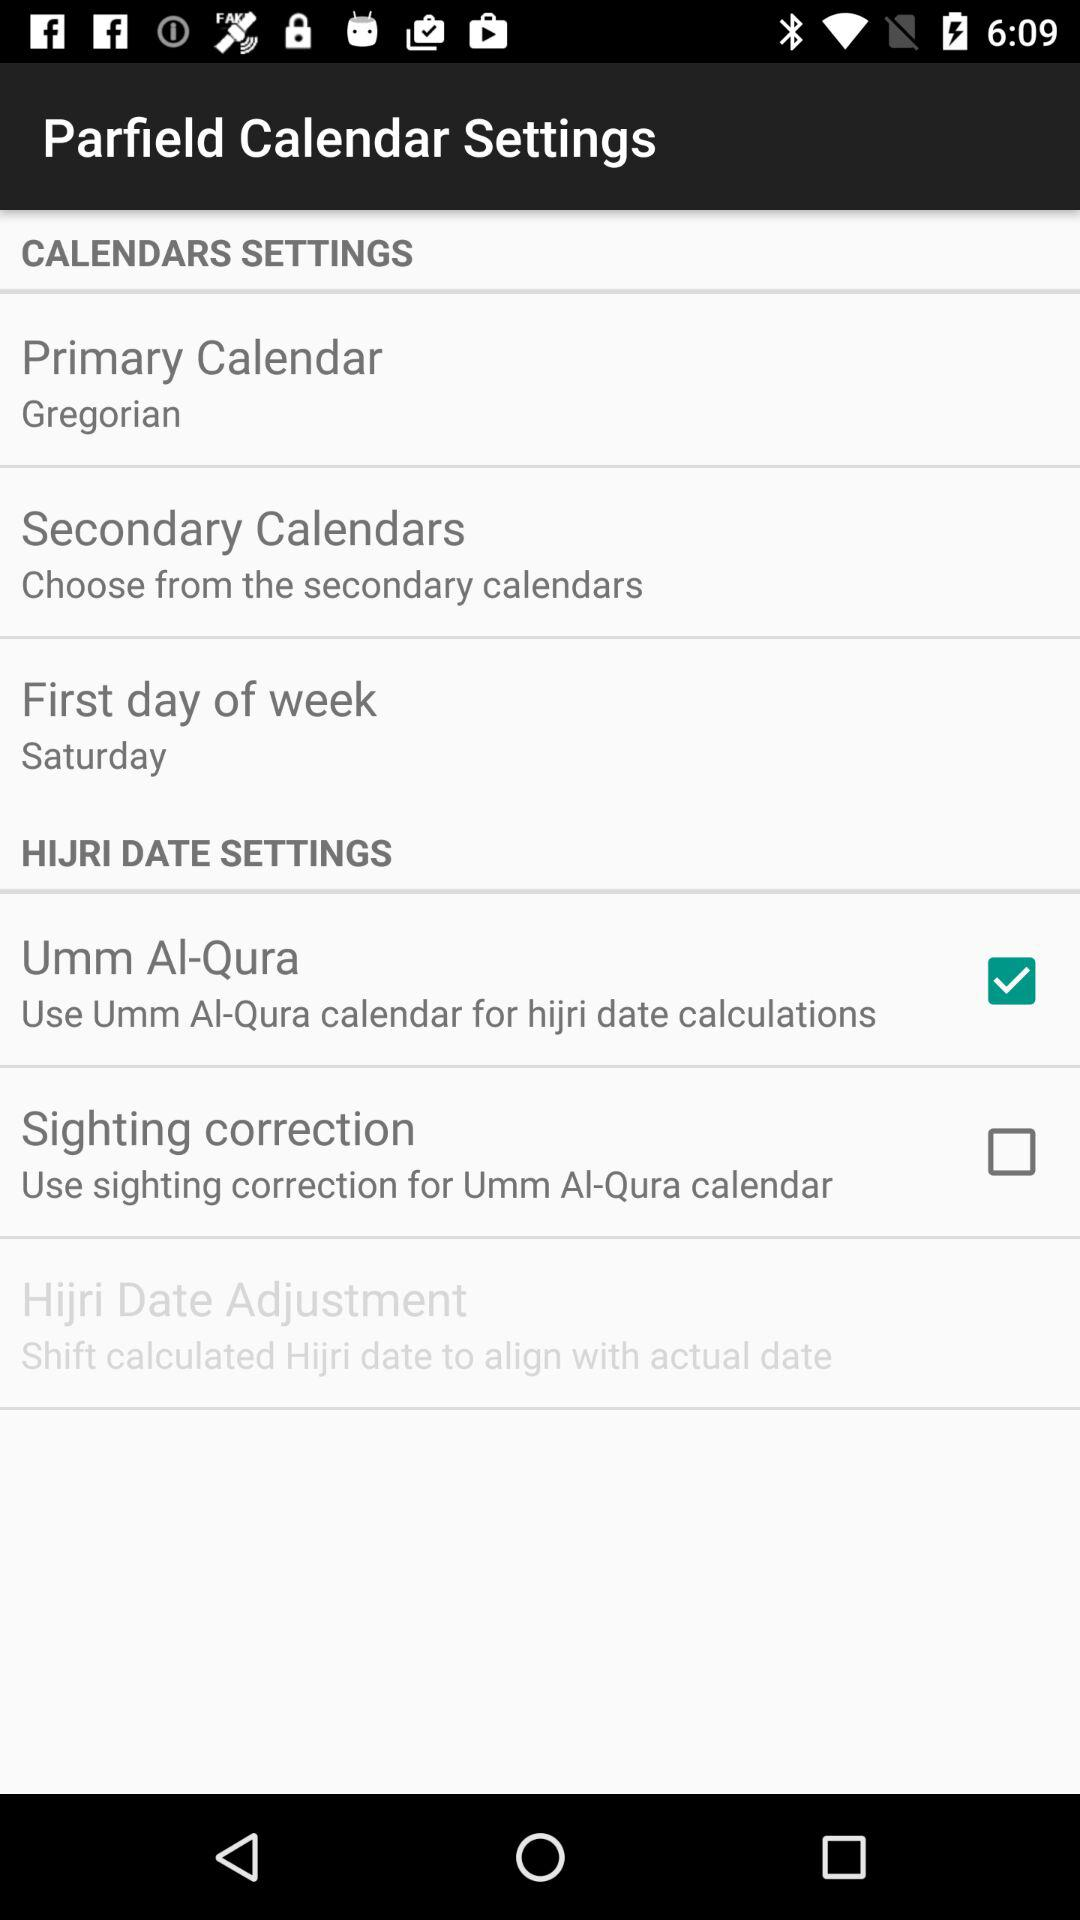What is the selected primary calendar? The selected primary calendar is Gregorian. 